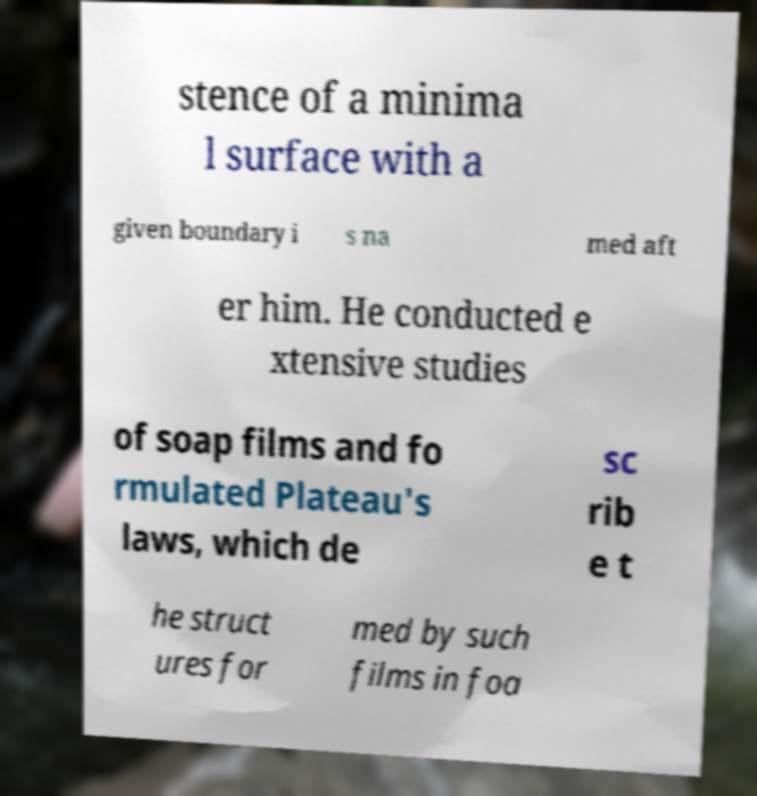I need the written content from this picture converted into text. Can you do that? stence of a minima l surface with a given boundary i s na med aft er him. He conducted e xtensive studies of soap films and fo rmulated Plateau's laws, which de sc rib e t he struct ures for med by such films in foa 